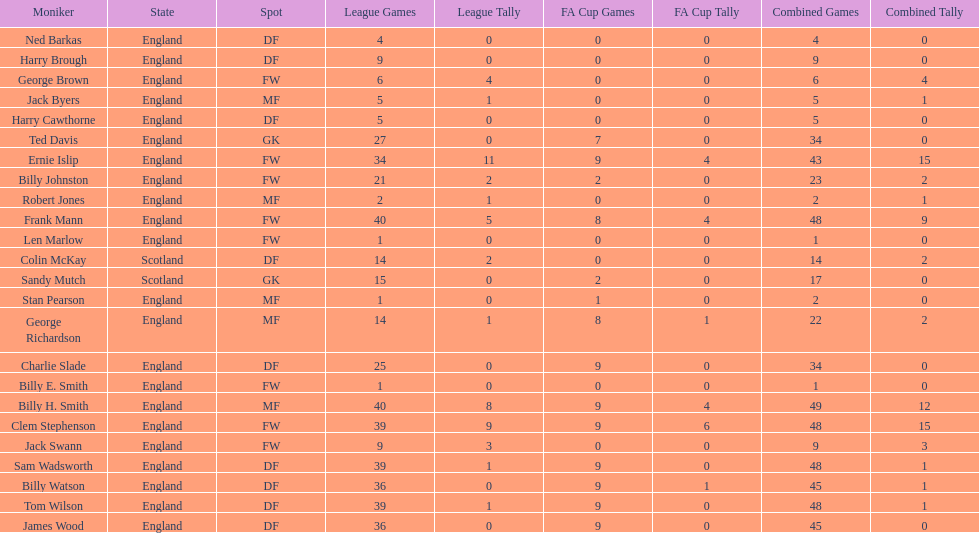What is the first name listed? Ned Barkas. 